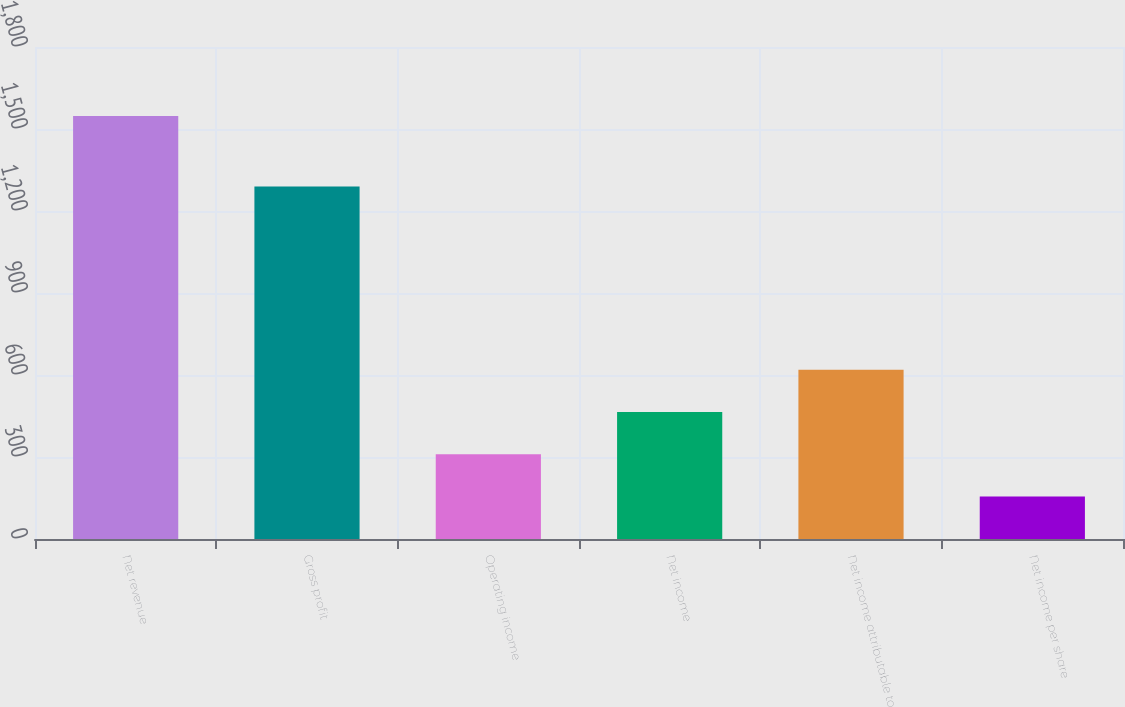Convert chart. <chart><loc_0><loc_0><loc_500><loc_500><bar_chart><fcel>Net revenue<fcel>Gross profit<fcel>Operating income<fcel>Net income<fcel>Net income attributable to<fcel>Net income per share<nl><fcel>1548<fcel>1290<fcel>309.89<fcel>464.65<fcel>619.41<fcel>155.13<nl></chart> 